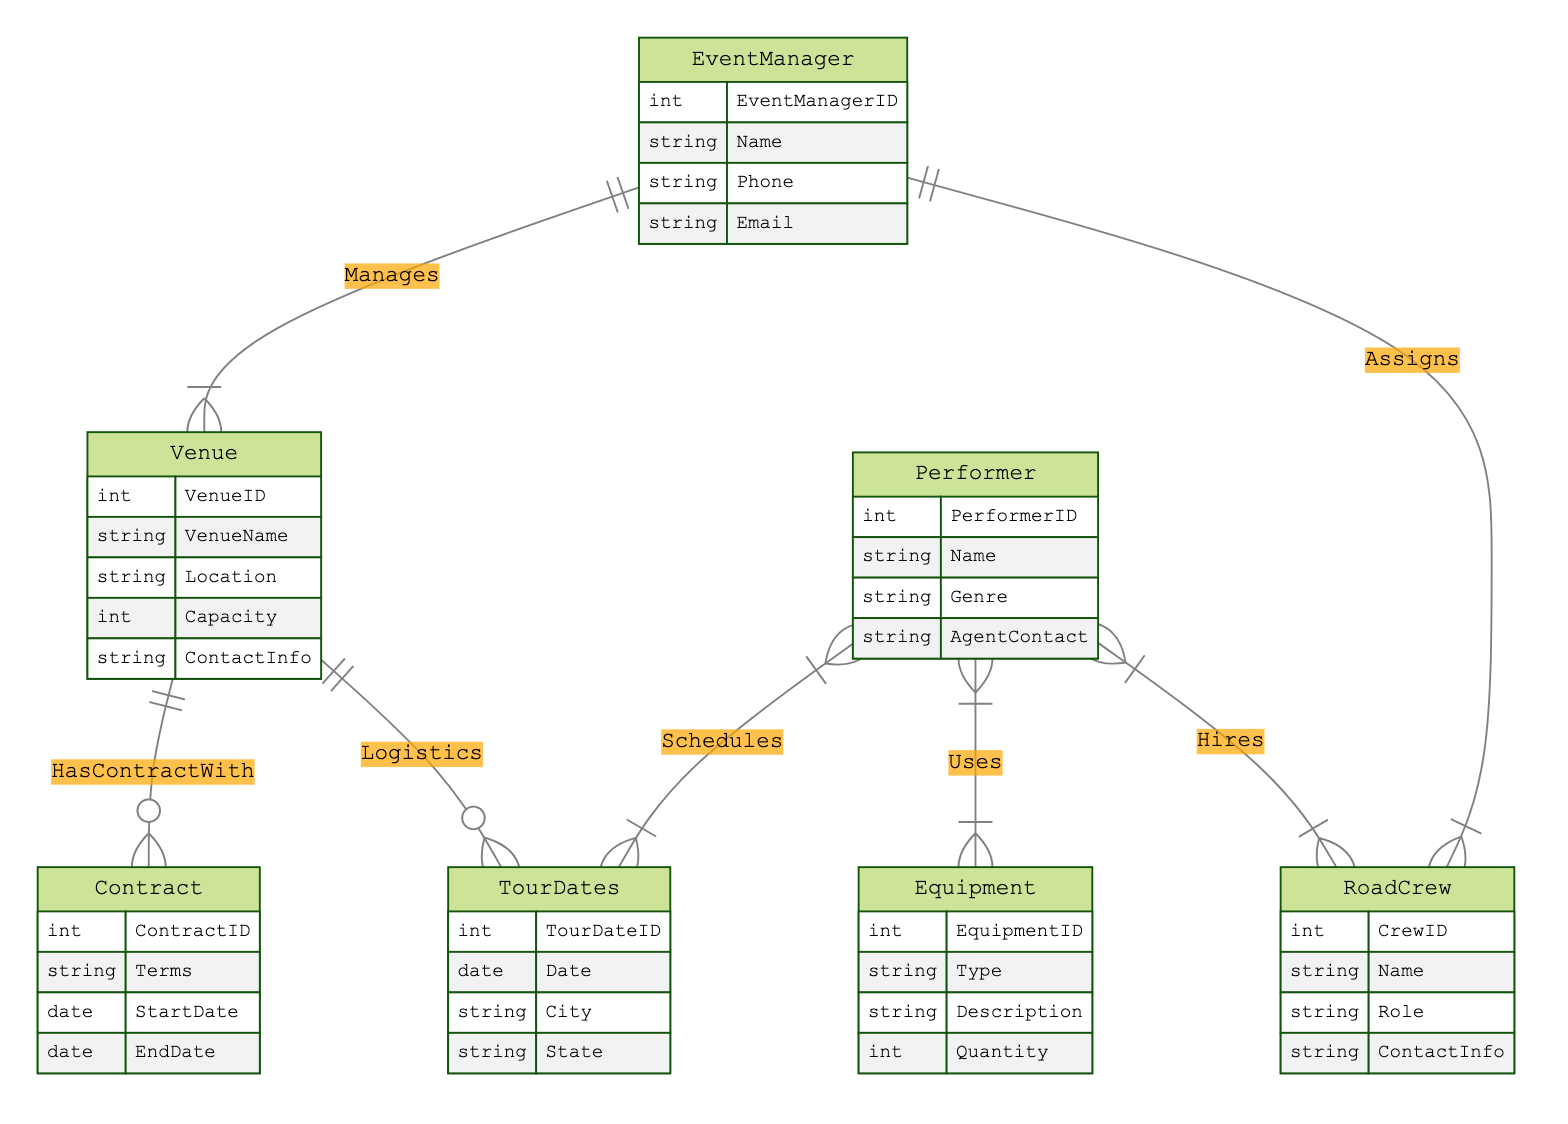What is the maximum number of entities in the diagram? The diagram includes six entities: Venue, Event Manager, Tour Dates, Performer, Road Crew, Equipment, and Contract. Therefore, the maximum number of entities is seven.
Answer: seven Which entity has a relationship with the most other entities? By surveying the relationships, the Performer entity has connections to Tour Dates, Equipment, and Road Crew, resulting in three relationships; whereas others have lesser connections.
Answer: three What is the role associated with the Road Crew entity? The attributes of the Road Crew entity include 'CrewID', 'Name', 'Role', and 'ContactInfo'. Therefore, the specific role associated with the Road Crew is 'Role'.
Answer: Role What relationship connects Event Manager and Venue? The relationship that connects Event Manager and Venue is the 'Manages' relationship, which indicates that an Event Manager is responsible for overseeing the Venue.
Answer: Manages How many different relationship types are there in the diagram? The diagram showcases six unique relationship types: Schedules, Manages, Logistics, Assigns, Uses, and Hires. Thus, the total number of relationship types is six.
Answer: six Which entity is responsible for the contract management alongside the Venue? The Contract entity is responsible for contract management, specifically outlined by the 'HasContractWith' relationship with the Venue.
Answer: Contract What does the 'Uses' relationship imply about the Performer and Equipment? The 'Uses' relationship signifies that a Performer utilizes specific Equipment during performances, with attributes detailing their UsageSchedule.
Answer: uses Which attribute indicates the capacity of a Venue? The capacity information for a Venue is contained within the 'Capacity' attribute, which specifically represents its maximum limit for attendees.
Answer: Capacity 